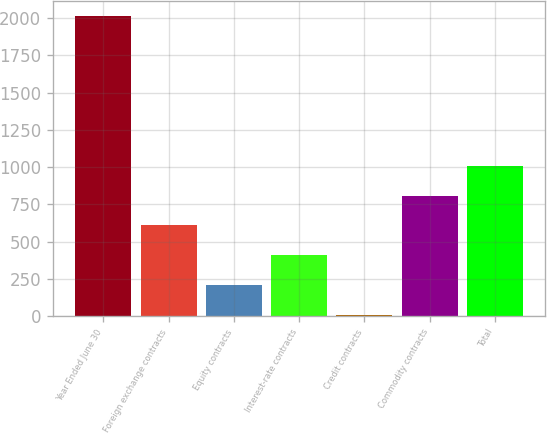Convert chart. <chart><loc_0><loc_0><loc_500><loc_500><bar_chart><fcel>Year Ended June 30<fcel>Foreign exchange contracts<fcel>Equity contracts<fcel>Interest-rate contracts<fcel>Credit contracts<fcel>Commodity contracts<fcel>Total<nl><fcel>2012<fcel>608.5<fcel>207.5<fcel>408<fcel>7<fcel>809<fcel>1009.5<nl></chart> 